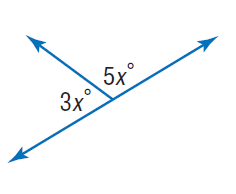Question: Find x.
Choices:
A. 22.5
B. 45
C. 60
D. 90
Answer with the letter. Answer: A 